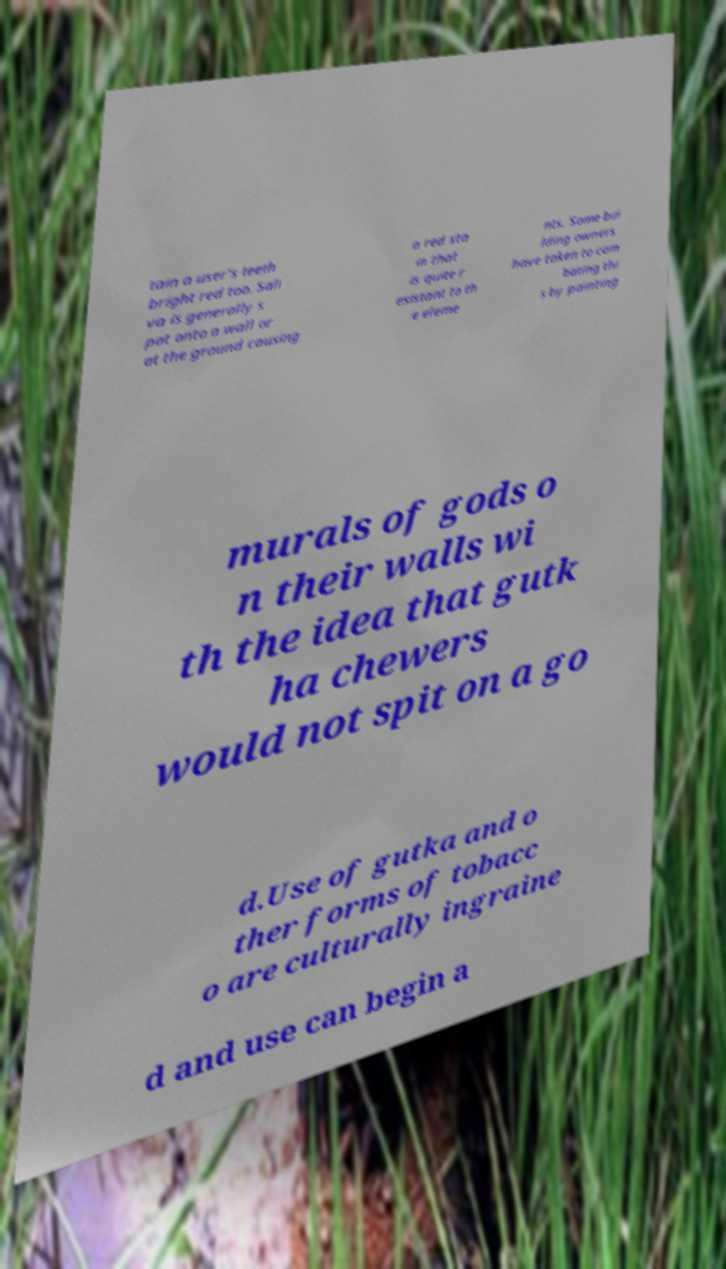Could you assist in decoding the text presented in this image and type it out clearly? tain a user's teeth bright red too. Sali va is generally s pat onto a wall or at the ground causing a red sta in that is quite r esistant to th e eleme nts. Some bui lding owners have taken to com bating thi s by painting murals of gods o n their walls wi th the idea that gutk ha chewers would not spit on a go d.Use of gutka and o ther forms of tobacc o are culturally ingraine d and use can begin a 